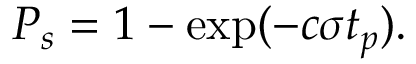<formula> <loc_0><loc_0><loc_500><loc_500>P _ { s } = 1 - \exp ( - c \sigma t _ { p } ) .</formula> 